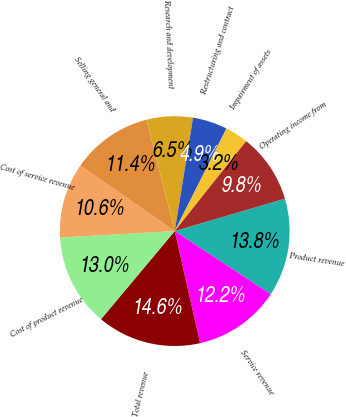Convert chart. <chart><loc_0><loc_0><loc_500><loc_500><pie_chart><fcel>Product revenue<fcel>Service revenue<fcel>Total revenue<fcel>Cost of product revenue<fcel>Cost of service revenue<fcel>Selling general and<fcel>Research and development<fcel>Restructuring and contract<fcel>Impairment of assets<fcel>Operating income from<nl><fcel>13.82%<fcel>12.2%<fcel>14.63%<fcel>13.01%<fcel>10.57%<fcel>11.38%<fcel>6.5%<fcel>4.88%<fcel>3.25%<fcel>9.76%<nl></chart> 